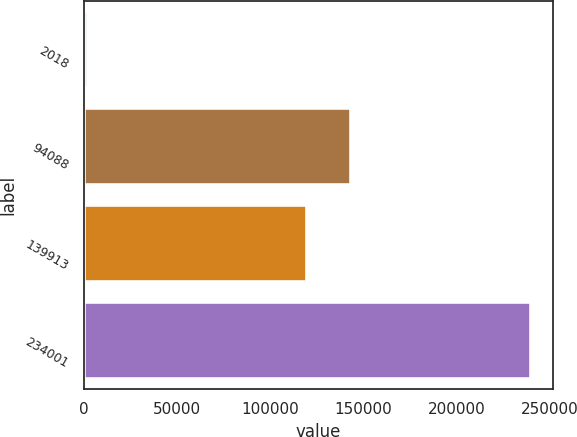Convert chart to OTSL. <chart><loc_0><loc_0><loc_500><loc_500><bar_chart><fcel>2018<fcel>94088<fcel>139913<fcel>234001<nl><fcel>2017<fcel>143172<fcel>119412<fcel>239620<nl></chart> 